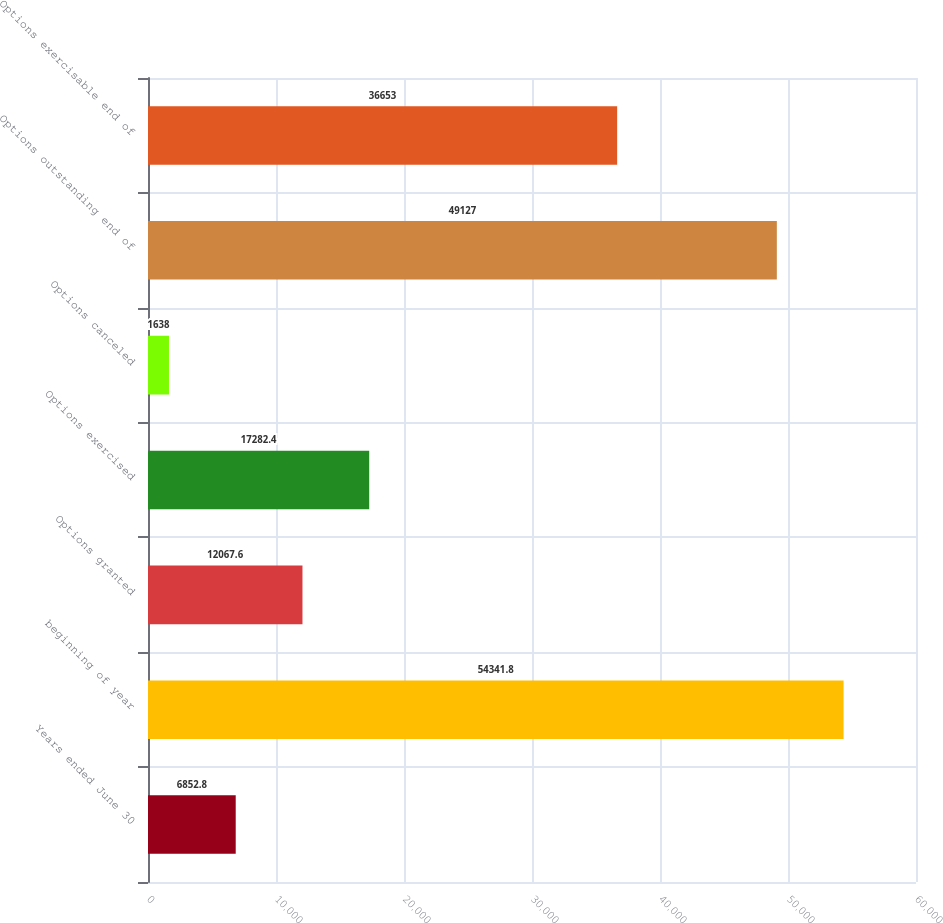Convert chart. <chart><loc_0><loc_0><loc_500><loc_500><bar_chart><fcel>Years ended June 30<fcel>beginning of year<fcel>Options granted<fcel>Options exercised<fcel>Options canceled<fcel>Options outstanding end of<fcel>Options exercisable end of<nl><fcel>6852.8<fcel>54341.8<fcel>12067.6<fcel>17282.4<fcel>1638<fcel>49127<fcel>36653<nl></chart> 